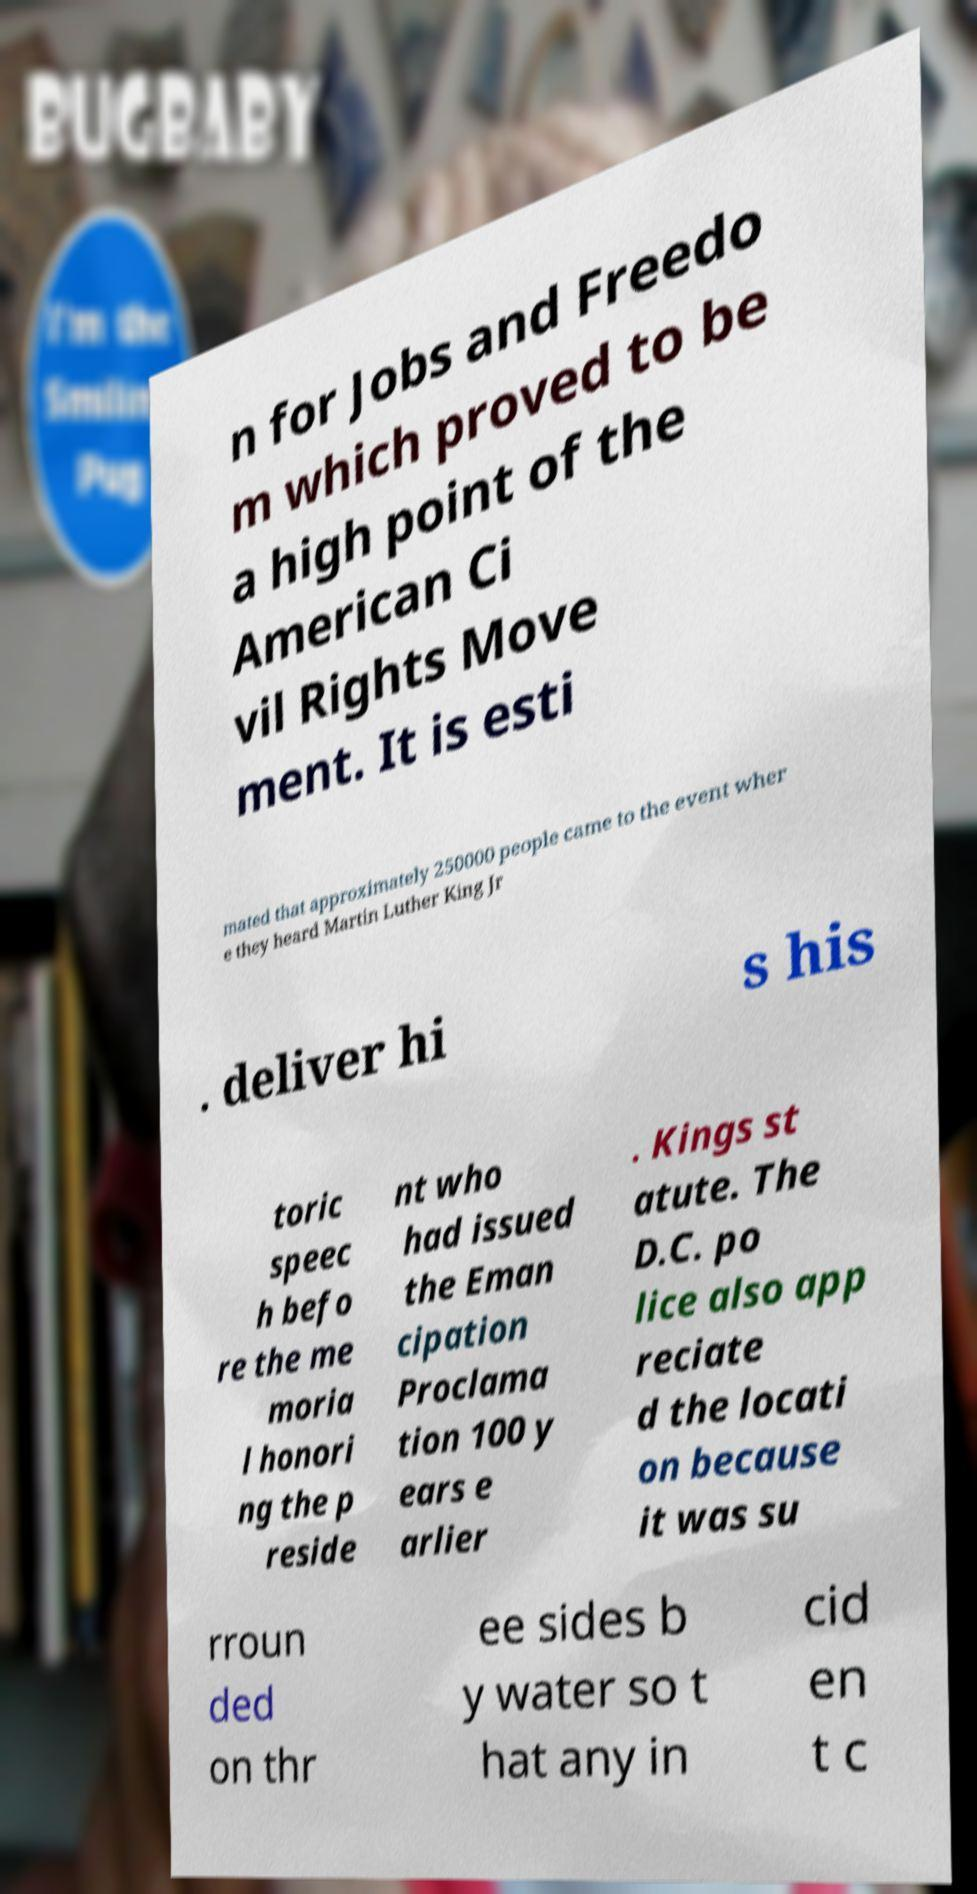Could you assist in decoding the text presented in this image and type it out clearly? n for Jobs and Freedo m which proved to be a high point of the American Ci vil Rights Move ment. It is esti mated that approximately 250000 people came to the event wher e they heard Martin Luther King Jr . deliver hi s his toric speec h befo re the me moria l honori ng the p reside nt who had issued the Eman cipation Proclama tion 100 y ears e arlier . Kings st atute. The D.C. po lice also app reciate d the locati on because it was su rroun ded on thr ee sides b y water so t hat any in cid en t c 